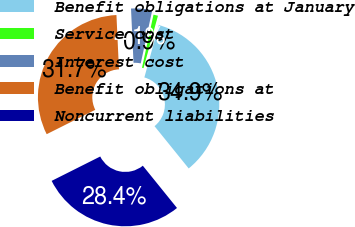Convert chart. <chart><loc_0><loc_0><loc_500><loc_500><pie_chart><fcel>Benefit obligations at January<fcel>Service cost<fcel>Interest cost<fcel>Benefit obligations at<fcel>Noncurrent liabilities<nl><fcel>34.9%<fcel>0.89%<fcel>4.13%<fcel>31.66%<fcel>28.42%<nl></chart> 